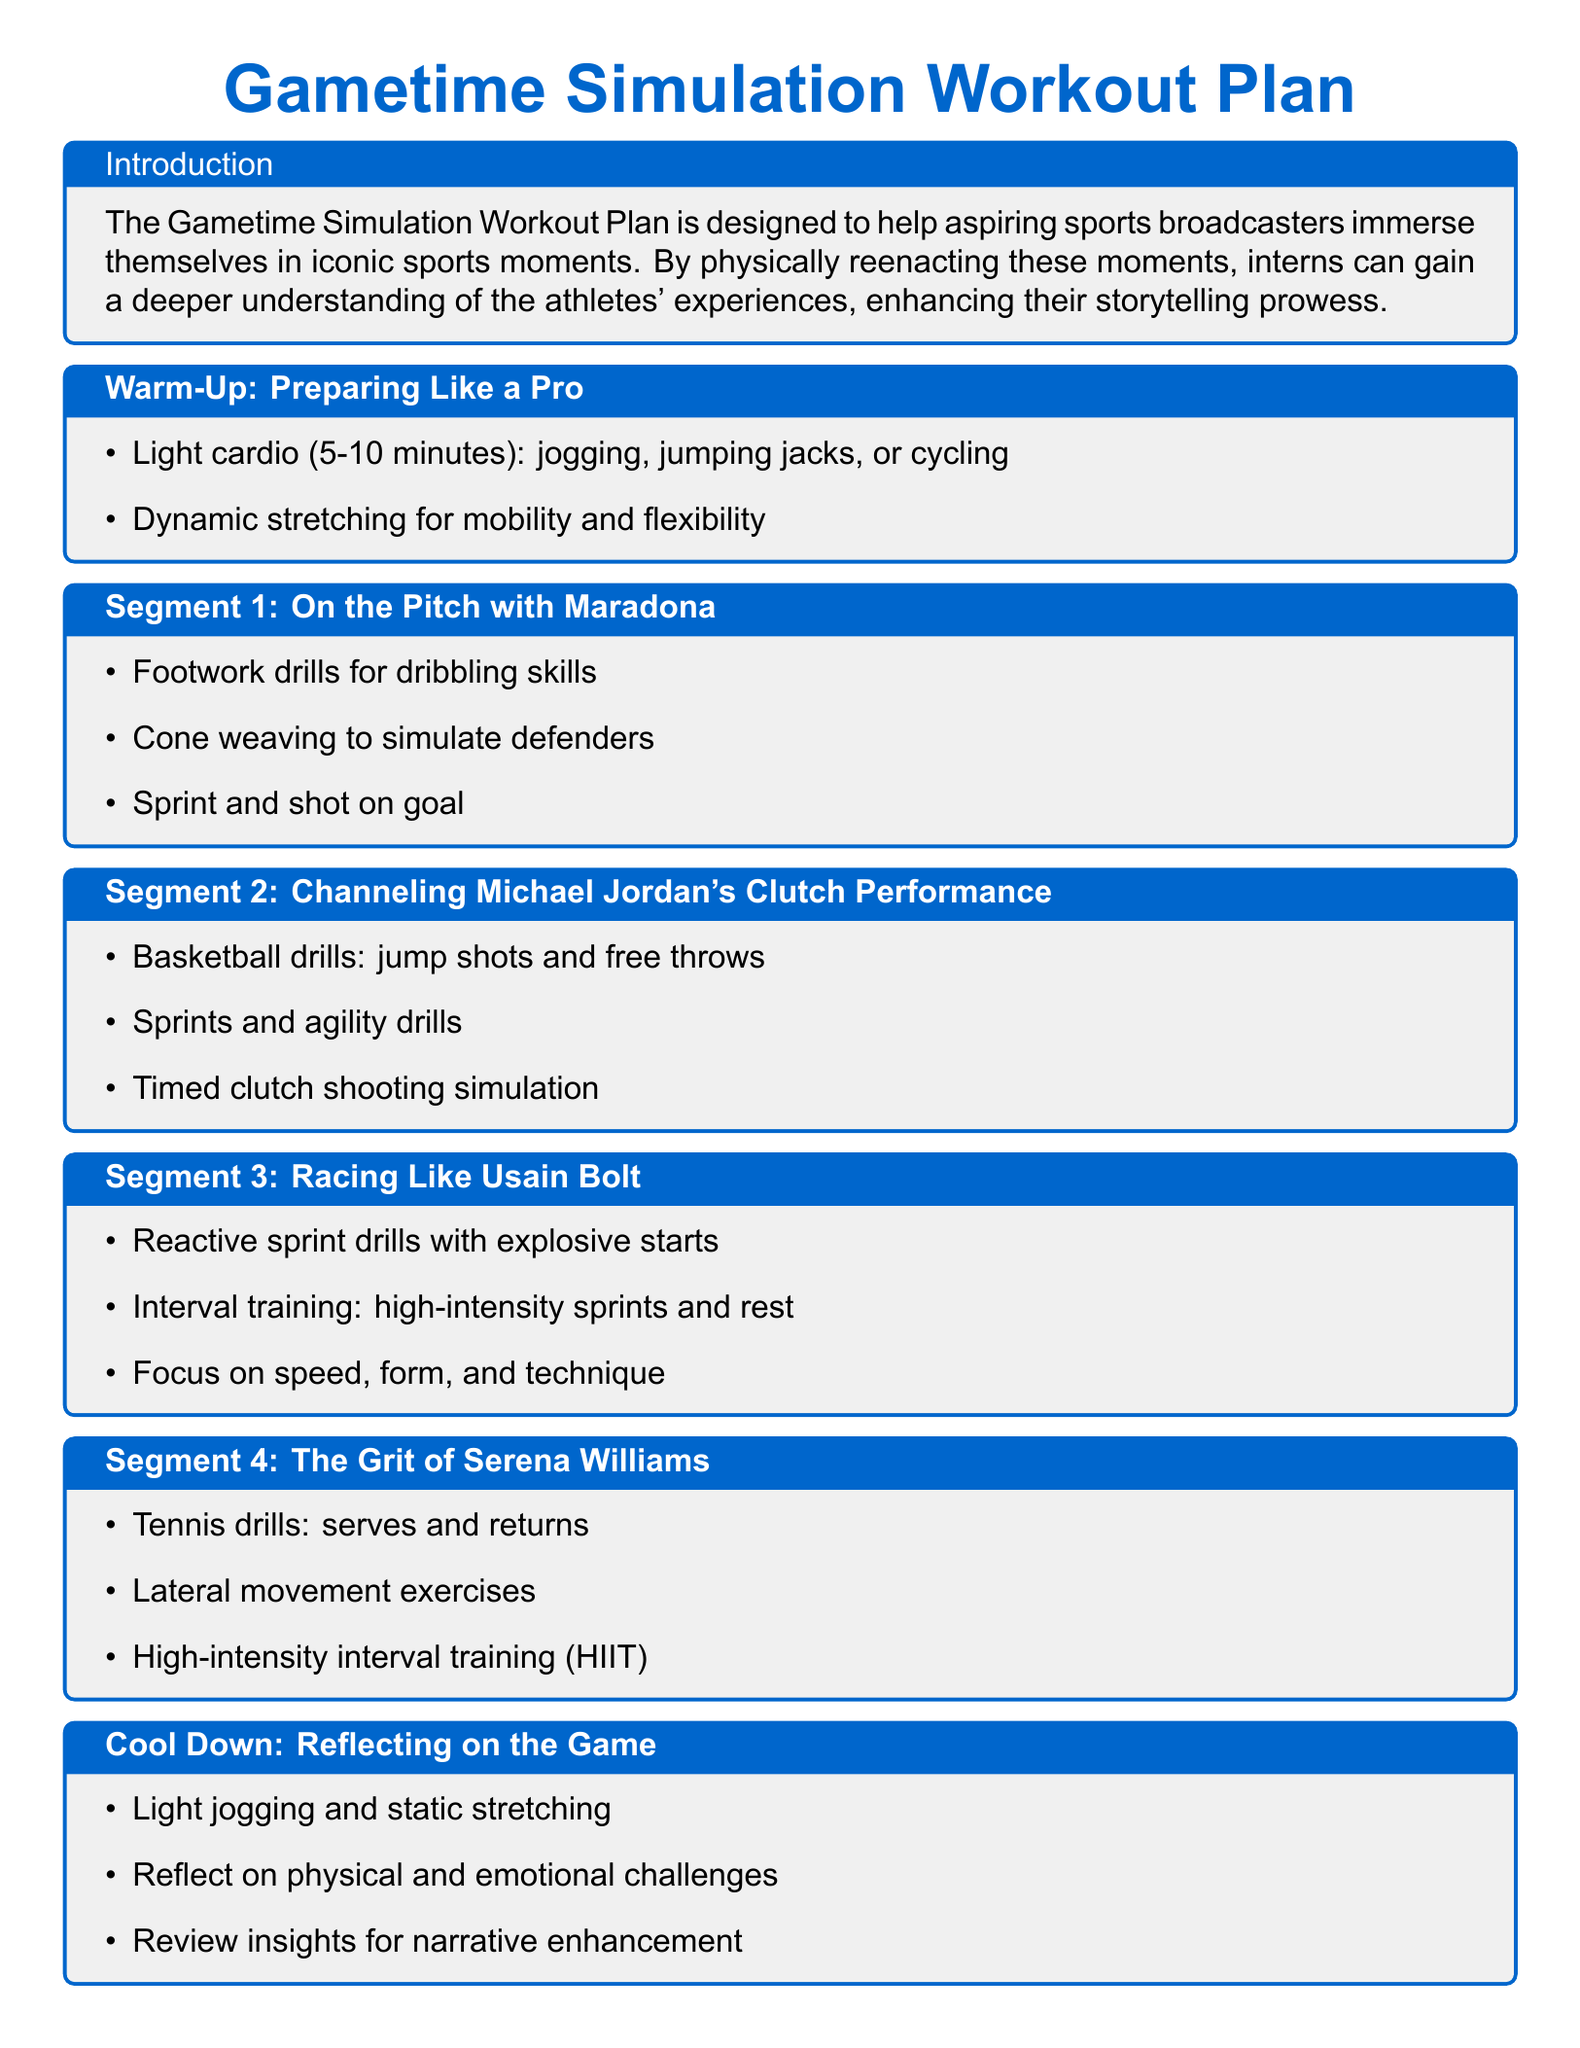What is the main purpose of the Gametime Simulation Workout Plan? The purpose is to help aspiring sports broadcasters immerse themselves in iconic sports moments and enhance their storytelling prowess.
Answer: Enhance storytelling prowess How many segments are included in the workout plan? The document lists five segments, including warm-up and cool down.
Answer: Five segments What sports figure is associated with Segment 1? Segment 1 is associated with Diego Maradona, focusing on dribbling skills and footwork.
Answer: Diego Maradona What exercise is included in Segment 3 for speed improvement? Segment 3 includes reactive sprint drills with explosive starts to improve speed.
Answer: Reactive sprint drills What type of training is emphasized in Segment 4? Segment 4 emphasizes high-intensity interval training (HIIT) to reflect Serena Williams' competitiveness.
Answer: High-intensity interval training What is the activity for cool down? The cool down includes light jogging and static stretching to help relax the body after the workout.
Answer: Light jogging and static stretching Which athlete's clutch performance is emulated in Segment 2? Segment 2 focuses on Michael Jordan's clutch performance through basketball drills.
Answer: Michael Jordan What is the first activity listed in the warm-up? The first activity listed is light cardio for 5-10 minutes, such as jogging or jumping jacks.
Answer: Light cardio 